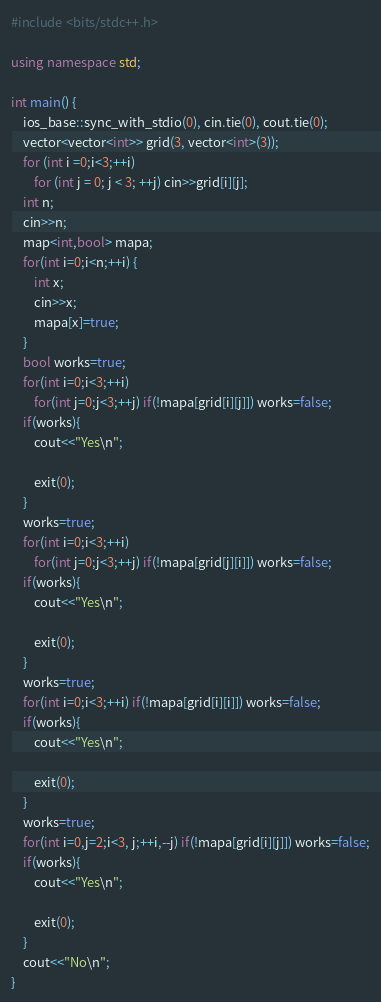Convert code to text. <code><loc_0><loc_0><loc_500><loc_500><_C++_>#include <bits/stdc++.h>

using namespace std;

int main() {
    ios_base::sync_with_stdio(0), cin.tie(0), cout.tie(0);
    vector<vector<int>> grid(3, vector<int>(3));
    for (int i =0;i<3;++i) 
        for (int j = 0; j < 3; ++j) cin>>grid[i][j];
    int n;
    cin>>n;
    map<int,bool> mapa;
    for(int i=0;i<n;++i) {
        int x;
        cin>>x;
        mapa[x]=true;
    }
    bool works=true;
    for(int i=0;i<3;++i)
        for(int j=0;j<3;++j) if(!mapa[grid[i][j]]) works=false;
    if(works){
        cout<<"Yes\n";
    
        exit(0);
    }
    works=true;
    for(int i=0;i<3;++i)
        for(int j=0;j<3;++j) if(!mapa[grid[j][i]]) works=false;
    if(works){
        cout<<"Yes\n";
    
        exit(0);
    }
    works=true;
    for(int i=0;i<3;++i) if(!mapa[grid[i][i]]) works=false;
    if(works){
        cout<<"Yes\n";
    
        exit(0);
    }
    works=true;
    for(int i=0,j=2;i<3, j;++i,--j) if(!mapa[grid[i][j]]) works=false;
    if(works){
        cout<<"Yes\n";
    
        exit(0);
    }
    cout<<"No\n";
}</code> 